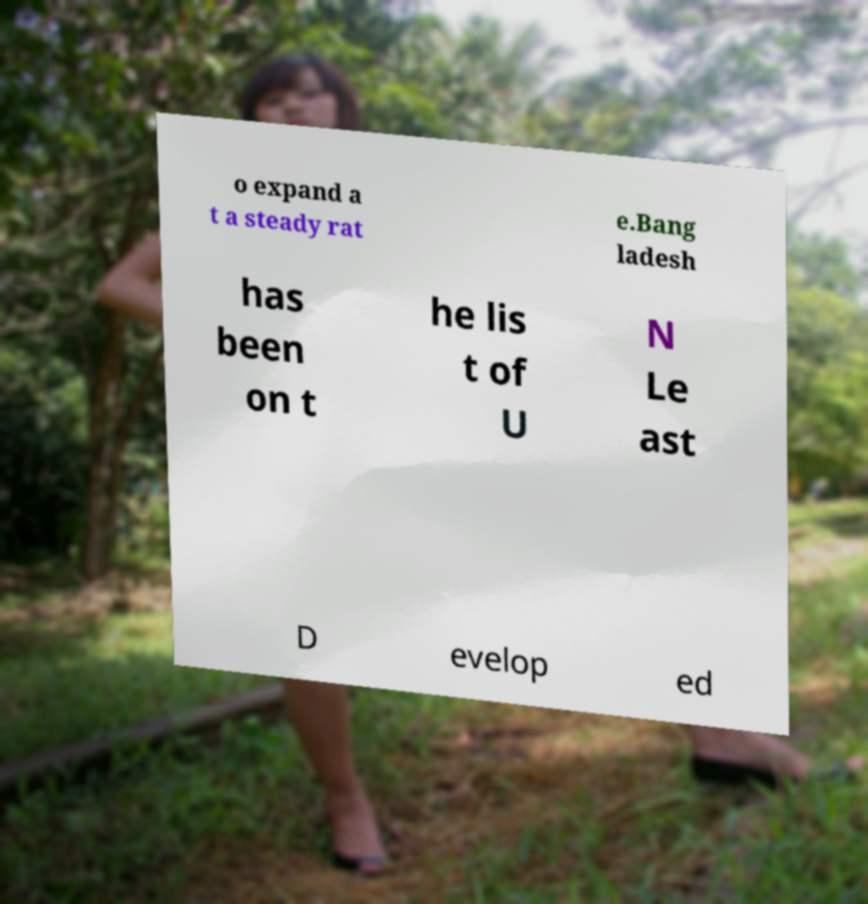Could you extract and type out the text from this image? o expand a t a steady rat e.Bang ladesh has been on t he lis t of U N Le ast D evelop ed 